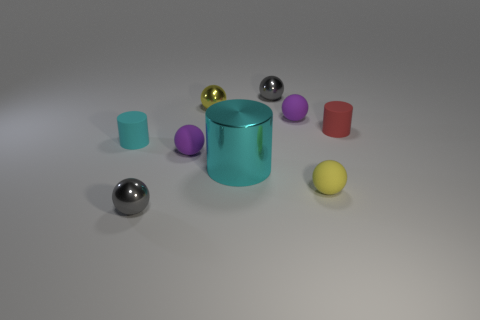Imagine these objects in a room with natural lighting. How might their appearance change? In natural lighting, we would likely see more nuanced highlights and shadows on these objects. Their true colors might also be more apparent, contrasting with the consistency of the studio lighting in the current image. 